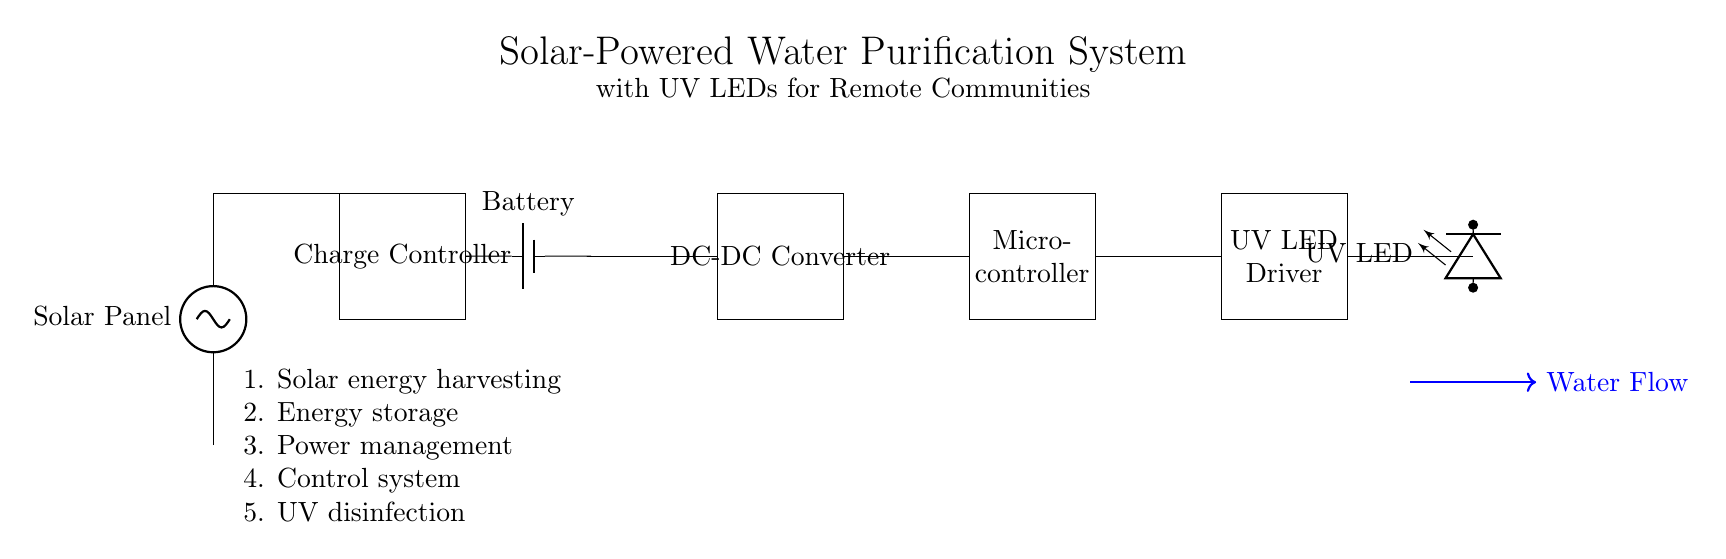What is the main energy source for this system? The main energy source is the solar panel, which converts solar energy into electrical energy to power the system.
Answer: solar panel What component regulates the battery charge? The charge controller manages the charging process to ensure that the battery does not overcharge, protecting it from damage.
Answer: charge controller What is the function of the microcontroller in this circuit? The microcontroller is responsible for controlling the overall operation of the system, including managing the UV LED driver based on water flow conditions.
Answer: control system How many main functional components are displayed in the circuit? There are five main functional components identified in the circuit: solar panel, charge controller, battery, DC-DC converter, and UV LED driver.
Answer: five How does the water flow through the system? The diagram shows a directional arrow indicating that water flows from the inlet towards the UV LEDs for purification before being discharged.
Answer: towards UV LEDs What is the role of the UV LED driver? The UV LED driver provides the necessary current and voltage to power the ultraviolet LEDs effectively for water purification.
Answer: power management What is the significance of using low power appliances in this work? Low power appliances ensure sustainability and efficiency, allowing the system to be operational in remote communities with limited energy resources.
Answer: sustainability 